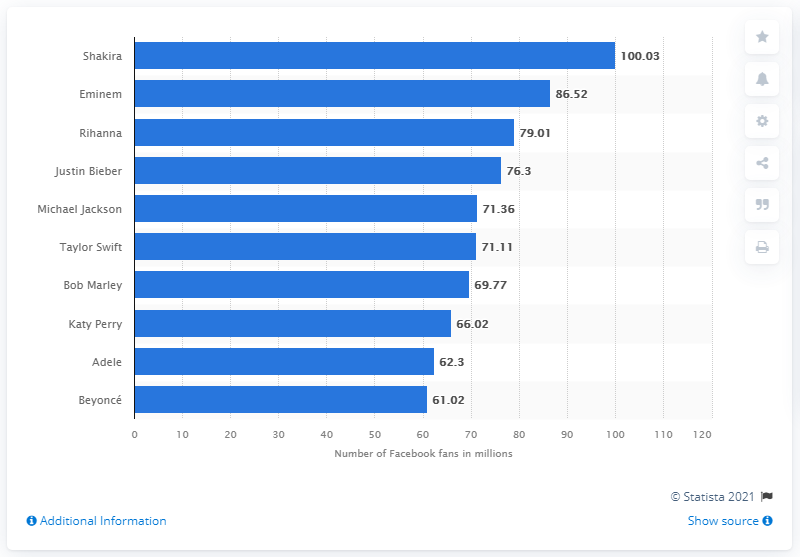Mention a couple of crucial points in this snapshot. Shakira, a popular Colombian singer, was the most popular on Facebook as of June 2021. 